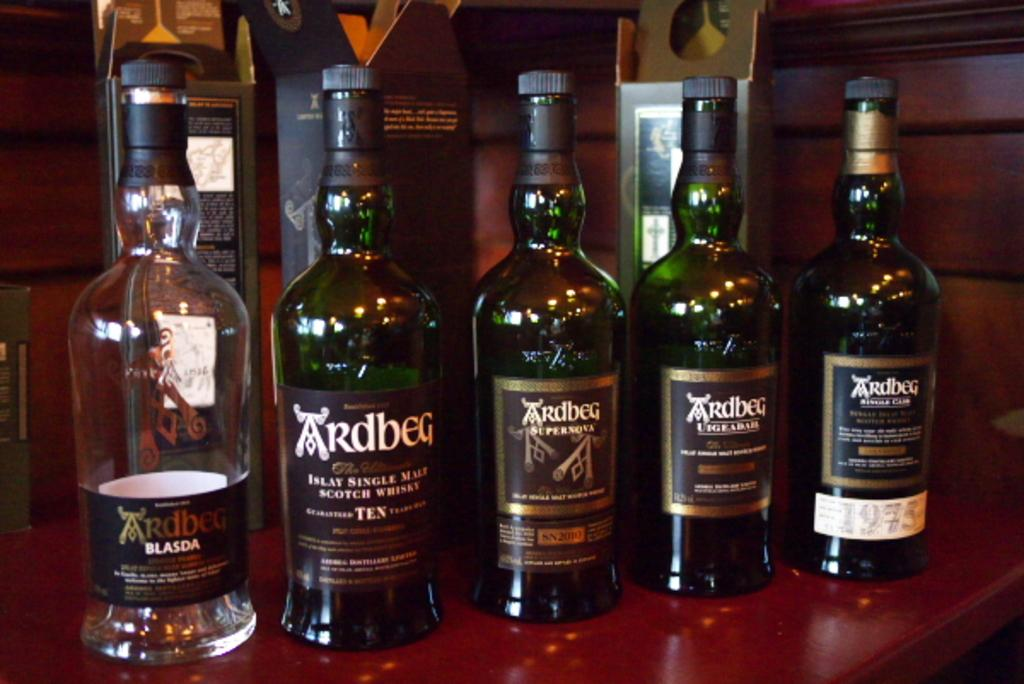What type of containers are visible in the image? There are glass bottles in the image. What accompanies the glass bottles in the image? There are glass bottle covers in the image. How many lines are visible on the glass bottles in the image? There is no mention of lines on the glass bottles in the provided facts, so we cannot determine the number of lines from the image. 